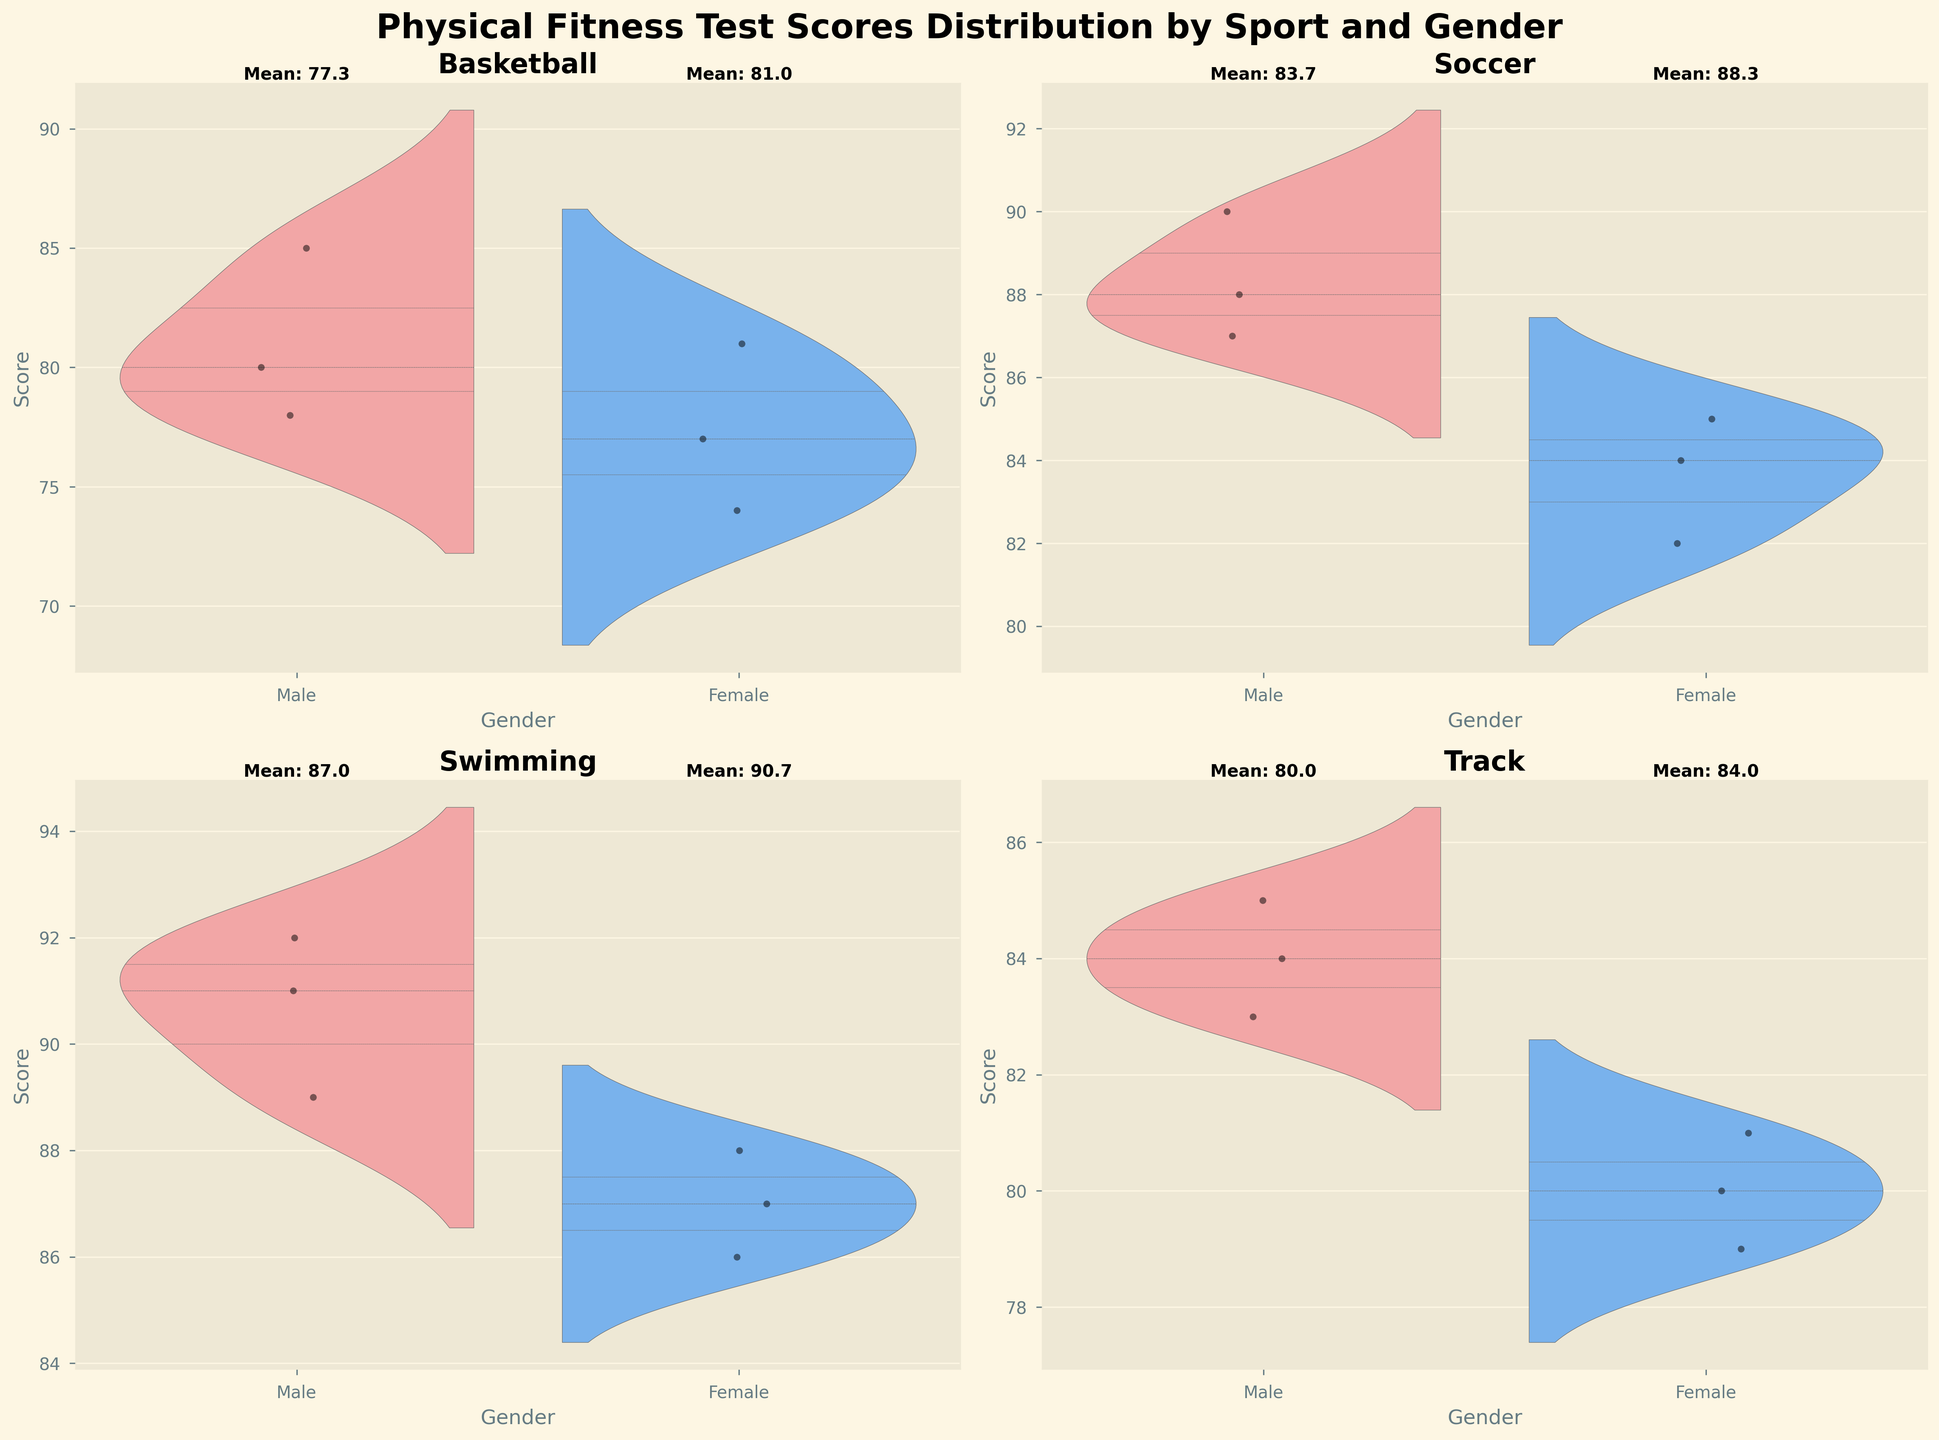What is the title of the figure? The title is usually found at the top of the chart. In the given plot, the title is specified to provide an overview of what the figure is about.
Answer: Physical Fitness Test Scores Distribution by Sport and Gender What are the two genders compared in the plot? The genders compared are indicated in the x-axis label of each subplot. By looking at the figure, you can see two distinct groups: Female and Male.
Answer: Female and Male Which sport has the highest mean score for male athletes? To determine this, look at the mean scores labeled above the male violin plots for each sport. Compare these values, and you will see that Swimming has the highest mean score for males.
Answer: Swimming For which sport is the mean score for female athletes the closest to 85? Examine the mean scores labeled above the female violin plots. Soccer has the mean score for females closest to 85, with a marked mean of around 84.
Answer: Soccer How does the score distribution for male Soccer players compare to female Soccer players? Look at the violin plot for Soccer. The width and shape of the violins show the distribution. Male scores are slightly higher and more narrowly distributed around the 88-90 range, whereas female scores are around 82-85.
Answer: Male scores are higher and more narrowly distributed What is the range of scores for female Basketball players? Observe the top and bottom extents of the violin plot for female Basketball players. Their scores range approximately from 74 to 81.
Answer: 74 to 81 Which gender has more variability in scores for Swimming? Look at the spread of the violin plots for both genders in Swimming. The male plot is more narrow compared to the female plot, indicating less variability in male scores.
Answer: Female Is the mean score for male Track athletes greater than that for female Track athletes? Compare the mean scores labeled above the violin plots for Track. The mean for male athletes is slightly higher than for female athletes, indicating that male Track athletes have a higher mean score.
Answer: Yes What is the shape of the violin plot for male Basketball players suggestive of? The shape of the violin plot shows how the scores are distributed. For male Basketball players, the violin plot appears wider in the middle, suggesting most scores are around the center (78-85).
Answer: A concentration of scores around the center What is the approximate mean score difference between male and female athletes in Swimming? Calculate the difference by subtracting the mean score of female Swimming athletes (around 87) from the mean score of male Swimming athletes (around 90).
Answer: Approximately 3 